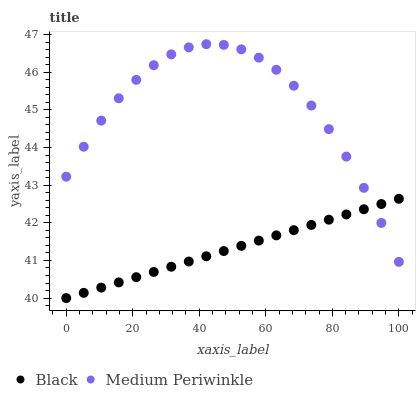Does Black have the minimum area under the curve?
Answer yes or no. Yes. Does Medium Periwinkle have the maximum area under the curve?
Answer yes or no. Yes. Does Black have the maximum area under the curve?
Answer yes or no. No. Is Black the smoothest?
Answer yes or no. Yes. Is Medium Periwinkle the roughest?
Answer yes or no. Yes. Is Black the roughest?
Answer yes or no. No. Does Black have the lowest value?
Answer yes or no. Yes. Does Medium Periwinkle have the highest value?
Answer yes or no. Yes. Does Black have the highest value?
Answer yes or no. No. Does Black intersect Medium Periwinkle?
Answer yes or no. Yes. Is Black less than Medium Periwinkle?
Answer yes or no. No. Is Black greater than Medium Periwinkle?
Answer yes or no. No. 